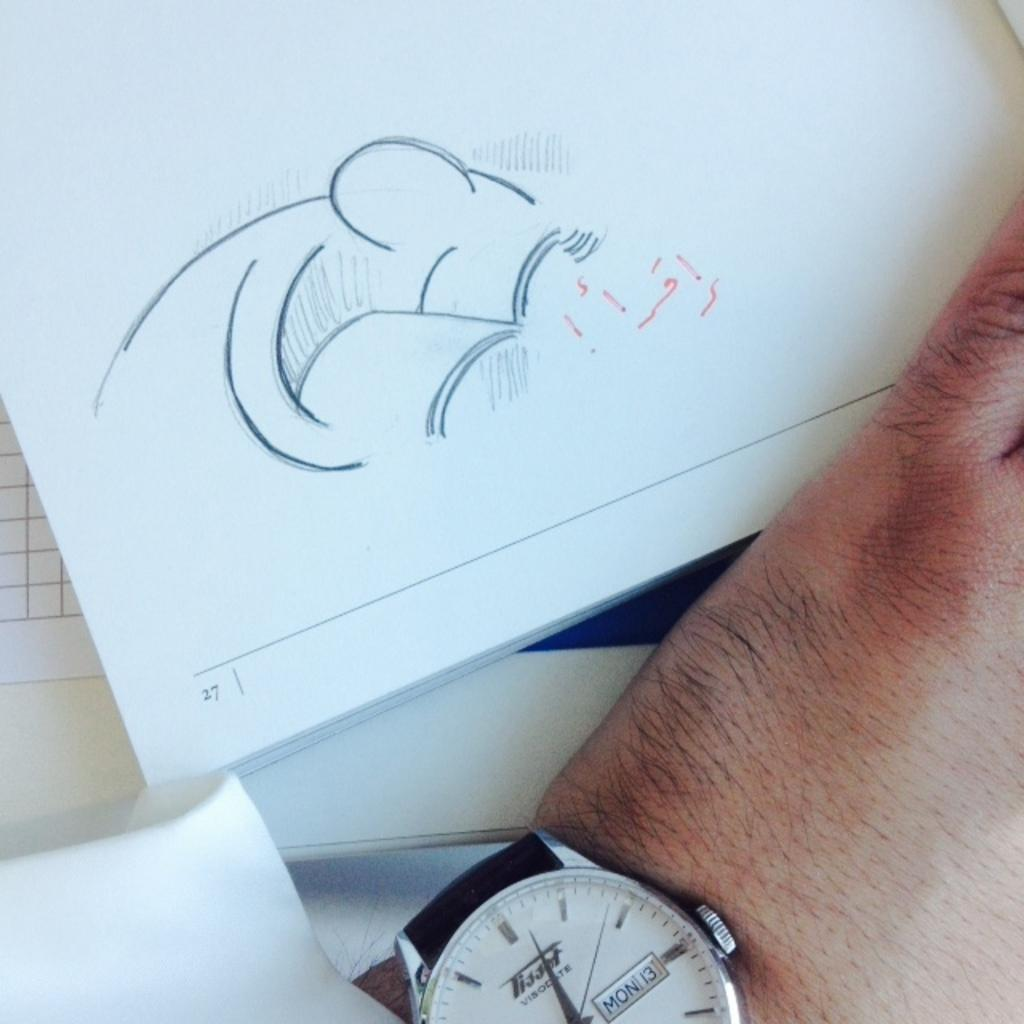<image>
Write a terse but informative summary of the picture. A Tissot watch says that today is Monday the 13th. 